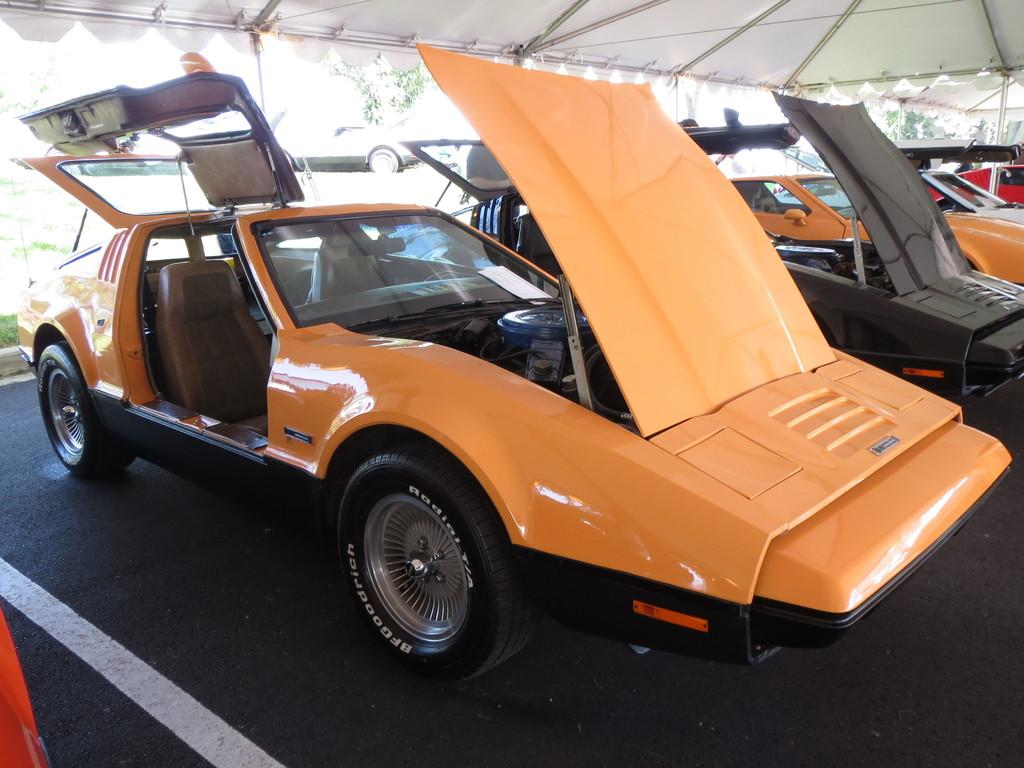What objects are on the floor in the image? There are vehicles on the floor in the image. Where are the vehicles located in relation to the tent? The vehicles are under a tent in the image. What type of natural elements can be seen in the image? There are trees visible in the image. What structures are present in the image? There are poles in the image. How many beds can be seen in the image? There are no beds present in the image. 